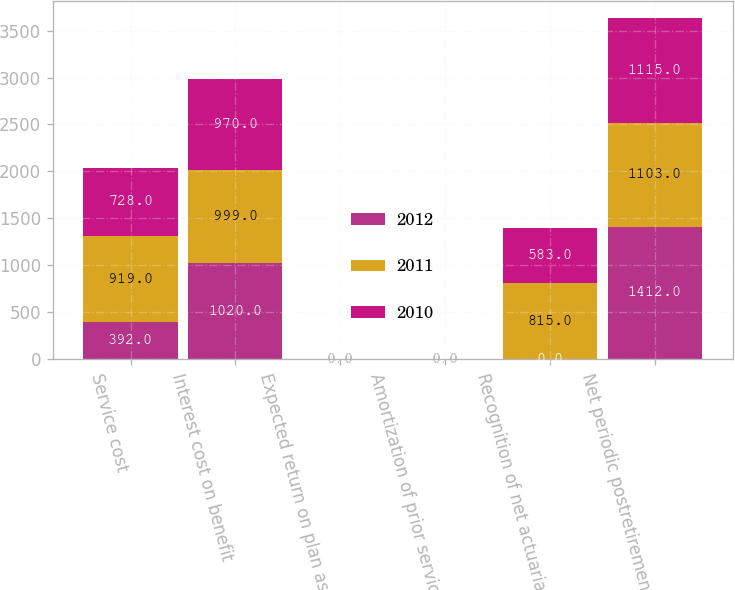<chart> <loc_0><loc_0><loc_500><loc_500><stacked_bar_chart><ecel><fcel>Service cost<fcel>Interest cost on benefit<fcel>Expected return on plan assets<fcel>Amortization of prior service<fcel>Recognition of net actuarial<fcel>Net periodic postretirement<nl><fcel>2012<fcel>392<fcel>1020<fcel>0<fcel>0<fcel>0<fcel>1412<nl><fcel>2011<fcel>919<fcel>999<fcel>0<fcel>0<fcel>815<fcel>1103<nl><fcel>2010<fcel>728<fcel>970<fcel>0<fcel>0<fcel>583<fcel>1115<nl></chart> 